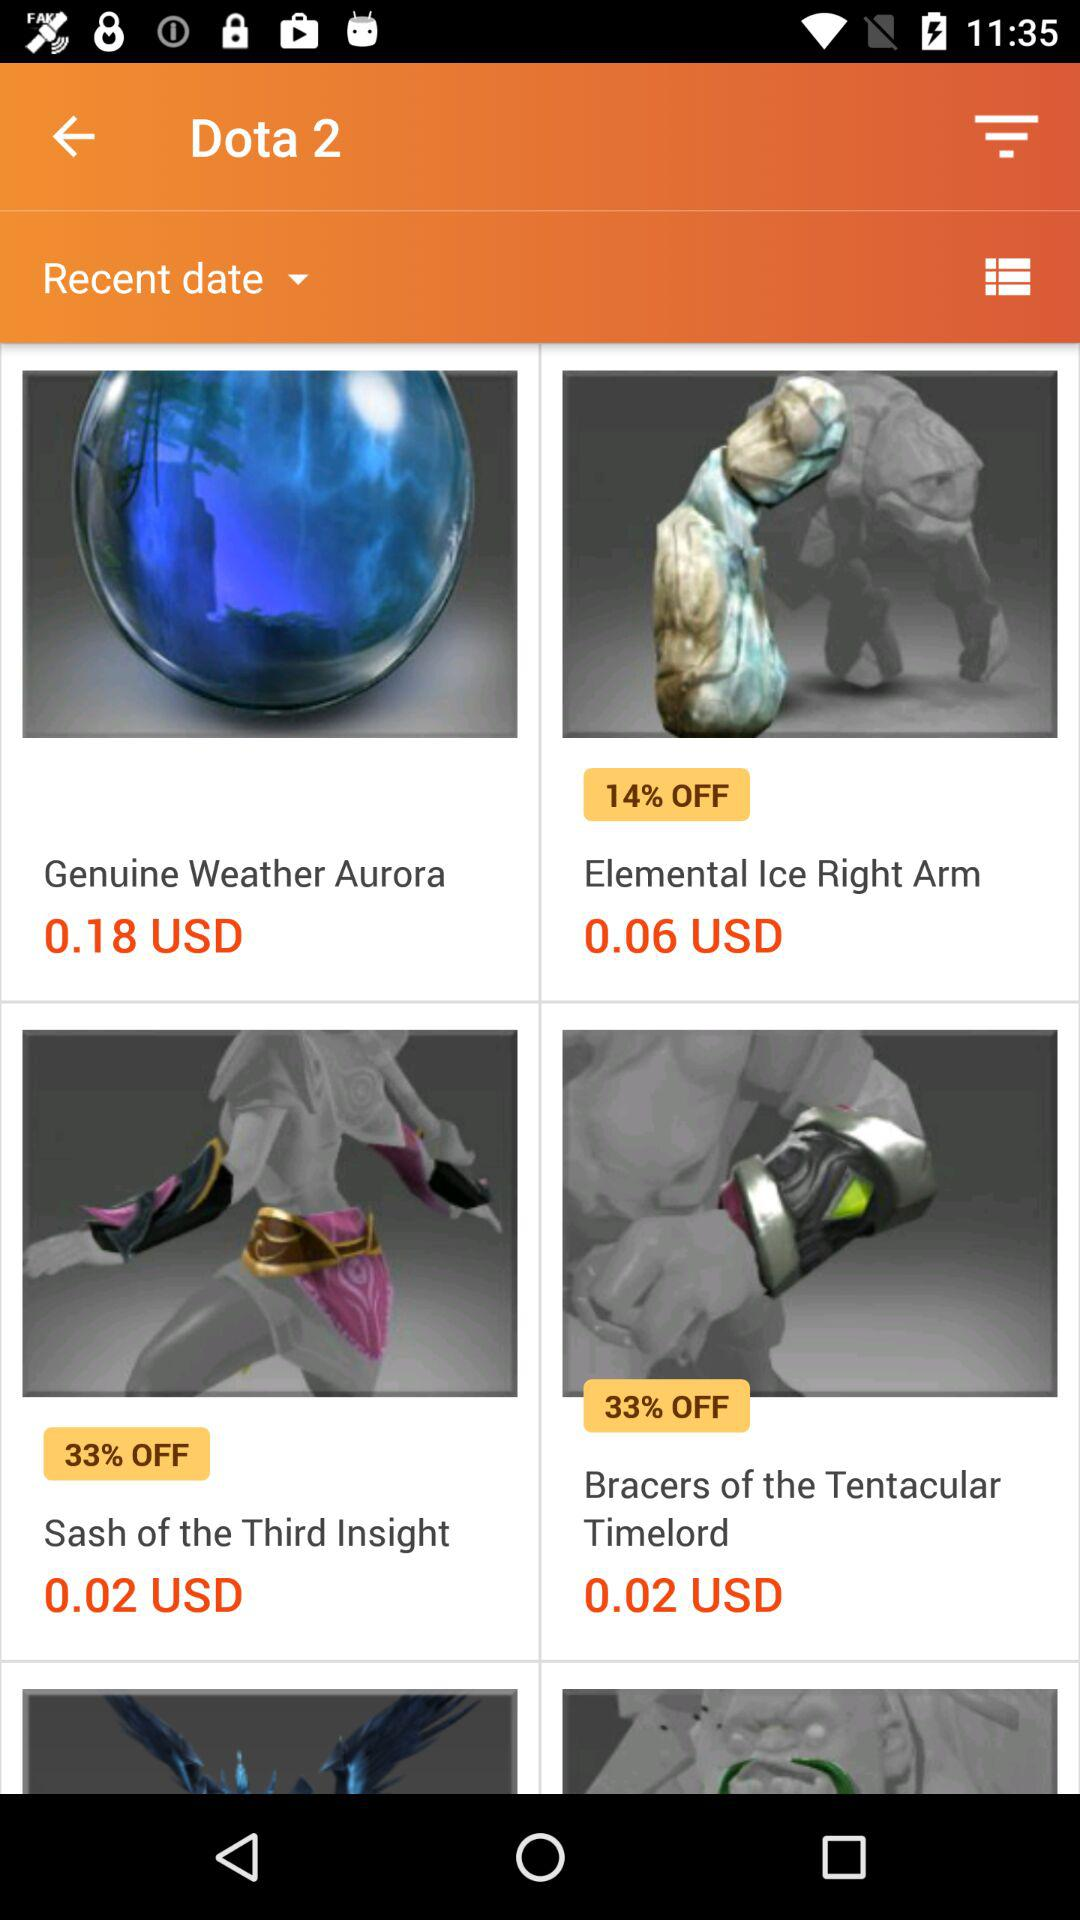What is the off given on "Sash of the Third Insight"? The given off on "Sash of the Third Insight" is 33%. 